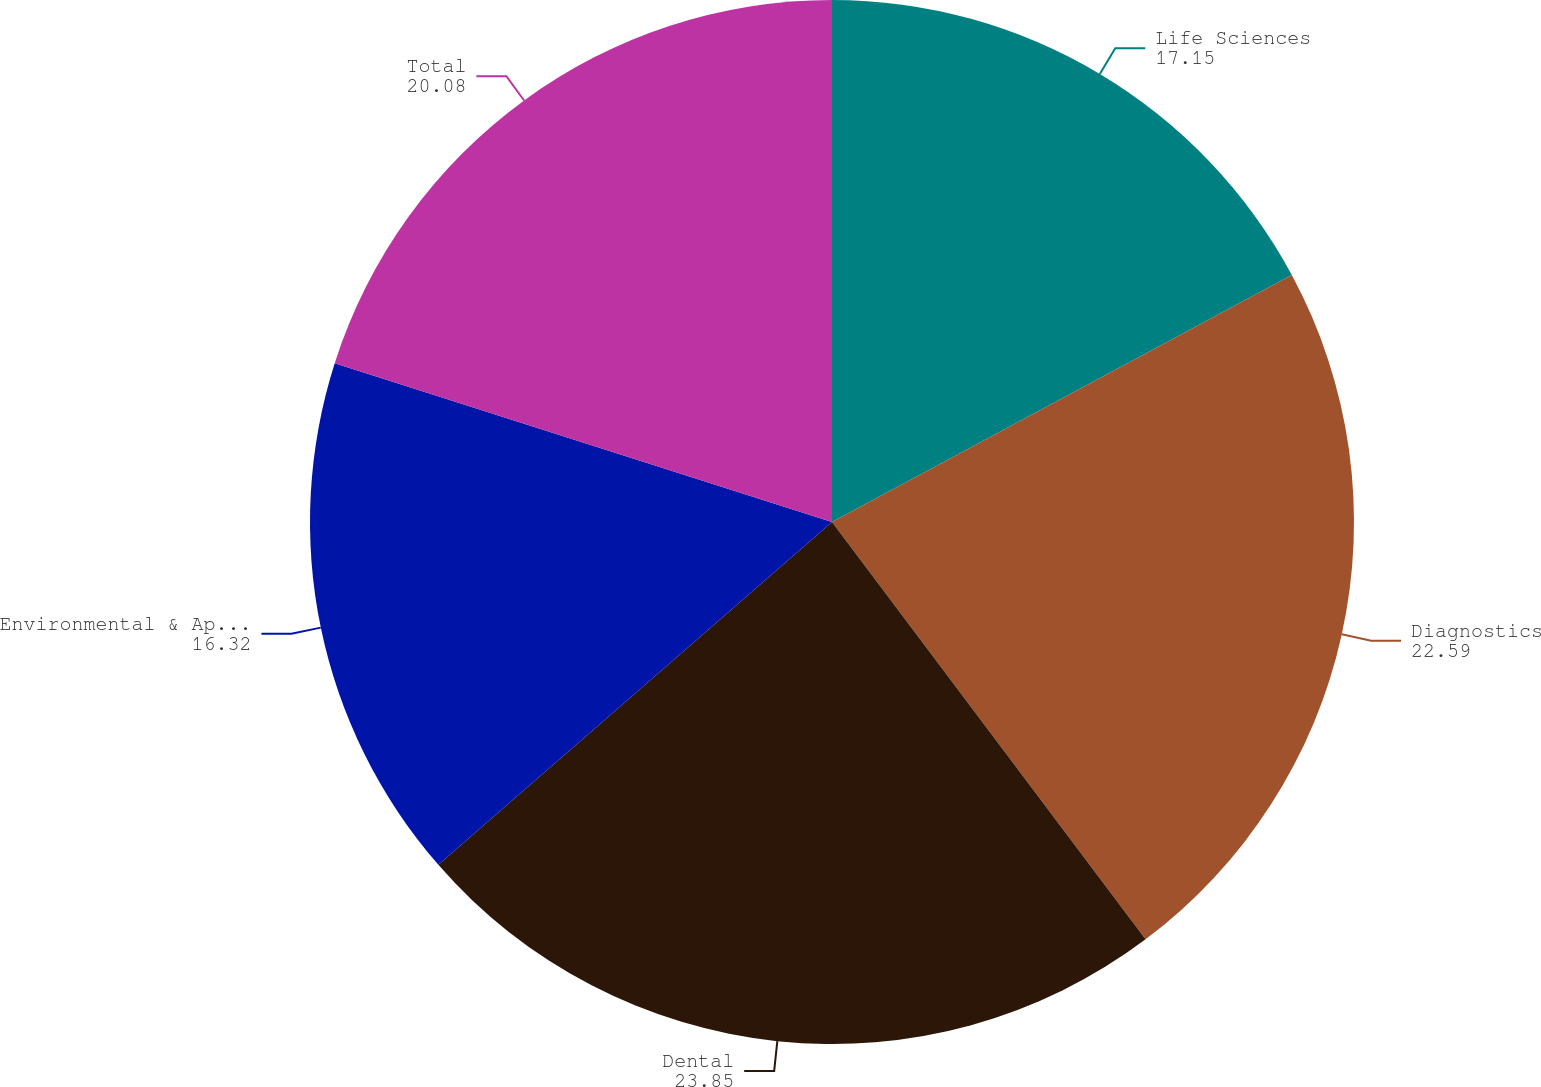Convert chart to OTSL. <chart><loc_0><loc_0><loc_500><loc_500><pie_chart><fcel>Life Sciences<fcel>Diagnostics<fcel>Dental<fcel>Environmental & Applied<fcel>Total<nl><fcel>17.15%<fcel>22.59%<fcel>23.85%<fcel>16.32%<fcel>20.08%<nl></chart> 